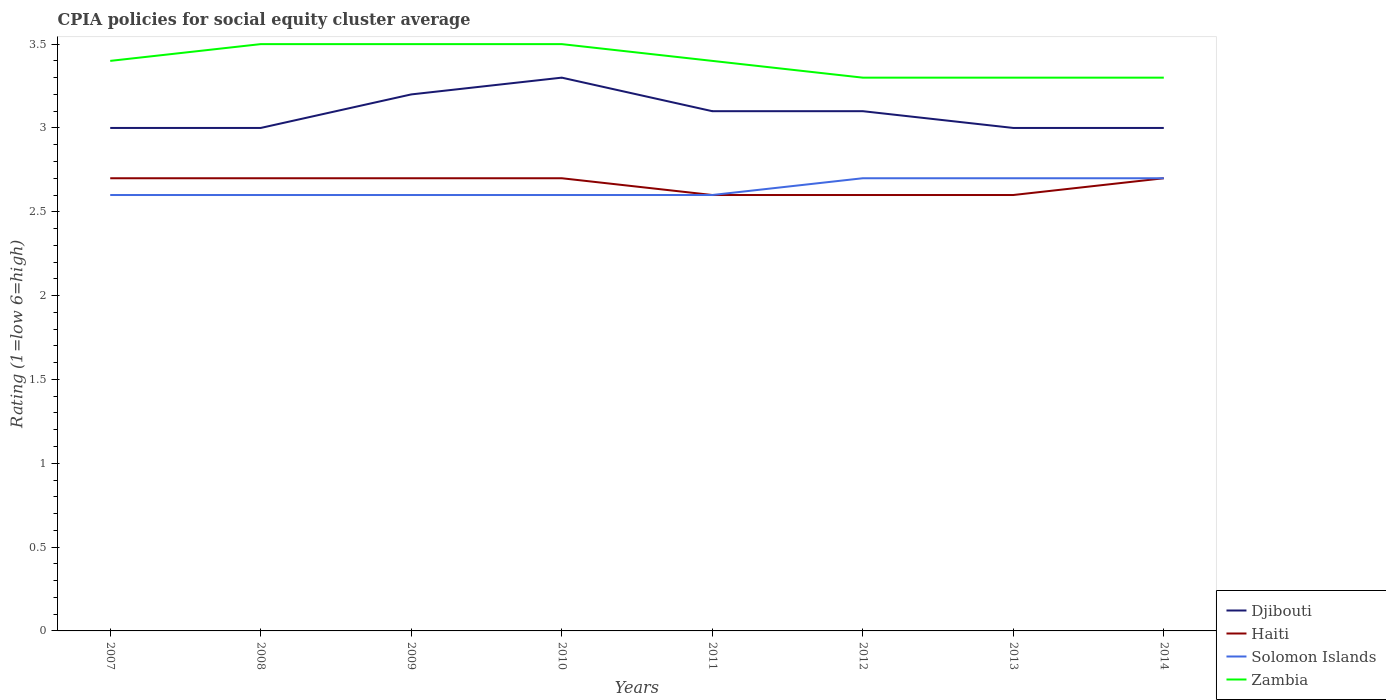Does the line corresponding to Solomon Islands intersect with the line corresponding to Zambia?
Make the answer very short. No. Across all years, what is the maximum CPIA rating in Djibouti?
Give a very brief answer. 3. In which year was the CPIA rating in Zambia maximum?
Give a very brief answer. 2012. What is the total CPIA rating in Djibouti in the graph?
Give a very brief answer. 0. What is the difference between the highest and the second highest CPIA rating in Djibouti?
Ensure brevity in your answer.  0.3. Is the CPIA rating in Djibouti strictly greater than the CPIA rating in Haiti over the years?
Your answer should be compact. No. Are the values on the major ticks of Y-axis written in scientific E-notation?
Your answer should be very brief. No. Does the graph contain any zero values?
Keep it short and to the point. No. Where does the legend appear in the graph?
Give a very brief answer. Bottom right. How many legend labels are there?
Your response must be concise. 4. How are the legend labels stacked?
Provide a short and direct response. Vertical. What is the title of the graph?
Your answer should be compact. CPIA policies for social equity cluster average. Does "Panama" appear as one of the legend labels in the graph?
Your answer should be very brief. No. What is the label or title of the X-axis?
Your answer should be very brief. Years. What is the Rating (1=low 6=high) of Djibouti in 2007?
Your response must be concise. 3. What is the Rating (1=low 6=high) of Haiti in 2007?
Offer a terse response. 2.7. What is the Rating (1=low 6=high) of Zambia in 2007?
Provide a succinct answer. 3.4. What is the Rating (1=low 6=high) in Haiti in 2008?
Your answer should be very brief. 2.7. What is the Rating (1=low 6=high) in Solomon Islands in 2008?
Offer a terse response. 2.6. What is the Rating (1=low 6=high) of Zambia in 2008?
Ensure brevity in your answer.  3.5. What is the Rating (1=low 6=high) of Zambia in 2009?
Offer a terse response. 3.5. What is the Rating (1=low 6=high) in Djibouti in 2010?
Provide a short and direct response. 3.3. What is the Rating (1=low 6=high) of Haiti in 2010?
Make the answer very short. 2.7. What is the Rating (1=low 6=high) in Solomon Islands in 2010?
Ensure brevity in your answer.  2.6. What is the Rating (1=low 6=high) in Zambia in 2010?
Provide a succinct answer. 3.5. What is the Rating (1=low 6=high) of Haiti in 2012?
Make the answer very short. 2.6. What is the Rating (1=low 6=high) in Haiti in 2013?
Keep it short and to the point. 2.6. What is the Rating (1=low 6=high) in Zambia in 2013?
Ensure brevity in your answer.  3.3. What is the Rating (1=low 6=high) of Zambia in 2014?
Your answer should be very brief. 3.3. Across all years, what is the maximum Rating (1=low 6=high) of Solomon Islands?
Ensure brevity in your answer.  2.7. Across all years, what is the maximum Rating (1=low 6=high) in Zambia?
Offer a very short reply. 3.5. Across all years, what is the minimum Rating (1=low 6=high) in Haiti?
Provide a short and direct response. 2.6. What is the total Rating (1=low 6=high) of Djibouti in the graph?
Make the answer very short. 24.7. What is the total Rating (1=low 6=high) of Haiti in the graph?
Offer a very short reply. 21.3. What is the total Rating (1=low 6=high) of Solomon Islands in the graph?
Keep it short and to the point. 21.1. What is the total Rating (1=low 6=high) of Zambia in the graph?
Keep it short and to the point. 27.2. What is the difference between the Rating (1=low 6=high) of Zambia in 2007 and that in 2008?
Offer a very short reply. -0.1. What is the difference between the Rating (1=low 6=high) of Djibouti in 2007 and that in 2009?
Ensure brevity in your answer.  -0.2. What is the difference between the Rating (1=low 6=high) in Haiti in 2007 and that in 2009?
Ensure brevity in your answer.  0. What is the difference between the Rating (1=low 6=high) in Djibouti in 2007 and that in 2010?
Offer a terse response. -0.3. What is the difference between the Rating (1=low 6=high) in Solomon Islands in 2007 and that in 2010?
Offer a terse response. 0. What is the difference between the Rating (1=low 6=high) in Zambia in 2007 and that in 2010?
Your response must be concise. -0.1. What is the difference between the Rating (1=low 6=high) of Djibouti in 2007 and that in 2012?
Make the answer very short. -0.1. What is the difference between the Rating (1=low 6=high) in Haiti in 2007 and that in 2012?
Give a very brief answer. 0.1. What is the difference between the Rating (1=low 6=high) of Solomon Islands in 2007 and that in 2012?
Give a very brief answer. -0.1. What is the difference between the Rating (1=low 6=high) of Zambia in 2007 and that in 2012?
Offer a very short reply. 0.1. What is the difference between the Rating (1=low 6=high) in Djibouti in 2007 and that in 2014?
Make the answer very short. 0. What is the difference between the Rating (1=low 6=high) of Solomon Islands in 2007 and that in 2014?
Your answer should be compact. -0.1. What is the difference between the Rating (1=low 6=high) of Zambia in 2007 and that in 2014?
Ensure brevity in your answer.  0.1. What is the difference between the Rating (1=low 6=high) in Djibouti in 2008 and that in 2009?
Keep it short and to the point. -0.2. What is the difference between the Rating (1=low 6=high) of Haiti in 2008 and that in 2009?
Provide a short and direct response. 0. What is the difference between the Rating (1=low 6=high) in Zambia in 2008 and that in 2009?
Give a very brief answer. 0. What is the difference between the Rating (1=low 6=high) in Haiti in 2008 and that in 2010?
Give a very brief answer. 0. What is the difference between the Rating (1=low 6=high) of Haiti in 2008 and that in 2011?
Your response must be concise. 0.1. What is the difference between the Rating (1=low 6=high) of Zambia in 2008 and that in 2011?
Offer a very short reply. 0.1. What is the difference between the Rating (1=low 6=high) in Djibouti in 2008 and that in 2012?
Make the answer very short. -0.1. What is the difference between the Rating (1=low 6=high) of Solomon Islands in 2008 and that in 2012?
Provide a succinct answer. -0.1. What is the difference between the Rating (1=low 6=high) in Solomon Islands in 2008 and that in 2013?
Provide a succinct answer. -0.1. What is the difference between the Rating (1=low 6=high) of Zambia in 2008 and that in 2014?
Ensure brevity in your answer.  0.2. What is the difference between the Rating (1=low 6=high) of Djibouti in 2009 and that in 2010?
Your response must be concise. -0.1. What is the difference between the Rating (1=low 6=high) of Haiti in 2009 and that in 2010?
Offer a terse response. 0. What is the difference between the Rating (1=low 6=high) of Haiti in 2009 and that in 2011?
Ensure brevity in your answer.  0.1. What is the difference between the Rating (1=low 6=high) of Solomon Islands in 2009 and that in 2011?
Give a very brief answer. 0. What is the difference between the Rating (1=low 6=high) in Zambia in 2009 and that in 2012?
Offer a very short reply. 0.2. What is the difference between the Rating (1=low 6=high) in Djibouti in 2009 and that in 2013?
Offer a very short reply. 0.2. What is the difference between the Rating (1=low 6=high) in Haiti in 2009 and that in 2013?
Ensure brevity in your answer.  0.1. What is the difference between the Rating (1=low 6=high) in Solomon Islands in 2009 and that in 2013?
Your answer should be compact. -0.1. What is the difference between the Rating (1=low 6=high) of Djibouti in 2010 and that in 2011?
Keep it short and to the point. 0.2. What is the difference between the Rating (1=low 6=high) in Haiti in 2010 and that in 2011?
Your response must be concise. 0.1. What is the difference between the Rating (1=low 6=high) in Zambia in 2010 and that in 2011?
Make the answer very short. 0.1. What is the difference between the Rating (1=low 6=high) of Haiti in 2010 and that in 2012?
Keep it short and to the point. 0.1. What is the difference between the Rating (1=low 6=high) in Solomon Islands in 2010 and that in 2012?
Ensure brevity in your answer.  -0.1. What is the difference between the Rating (1=low 6=high) in Zambia in 2010 and that in 2012?
Offer a very short reply. 0.2. What is the difference between the Rating (1=low 6=high) of Djibouti in 2010 and that in 2013?
Give a very brief answer. 0.3. What is the difference between the Rating (1=low 6=high) in Djibouti in 2010 and that in 2014?
Offer a terse response. 0.3. What is the difference between the Rating (1=low 6=high) in Haiti in 2010 and that in 2014?
Keep it short and to the point. 0. What is the difference between the Rating (1=low 6=high) in Zambia in 2010 and that in 2014?
Provide a short and direct response. 0.2. What is the difference between the Rating (1=low 6=high) of Djibouti in 2011 and that in 2014?
Ensure brevity in your answer.  0.1. What is the difference between the Rating (1=low 6=high) in Haiti in 2011 and that in 2014?
Provide a succinct answer. -0.1. What is the difference between the Rating (1=low 6=high) in Solomon Islands in 2011 and that in 2014?
Your answer should be compact. -0.1. What is the difference between the Rating (1=low 6=high) of Zambia in 2011 and that in 2014?
Make the answer very short. 0.1. What is the difference between the Rating (1=low 6=high) of Djibouti in 2012 and that in 2014?
Offer a very short reply. 0.1. What is the difference between the Rating (1=low 6=high) in Solomon Islands in 2013 and that in 2014?
Ensure brevity in your answer.  0. What is the difference between the Rating (1=low 6=high) in Zambia in 2013 and that in 2014?
Give a very brief answer. 0. What is the difference between the Rating (1=low 6=high) of Djibouti in 2007 and the Rating (1=low 6=high) of Solomon Islands in 2008?
Your response must be concise. 0.4. What is the difference between the Rating (1=low 6=high) of Haiti in 2007 and the Rating (1=low 6=high) of Zambia in 2008?
Your response must be concise. -0.8. What is the difference between the Rating (1=low 6=high) in Djibouti in 2007 and the Rating (1=low 6=high) in Haiti in 2009?
Make the answer very short. 0.3. What is the difference between the Rating (1=low 6=high) in Djibouti in 2007 and the Rating (1=low 6=high) in Solomon Islands in 2009?
Make the answer very short. 0.4. What is the difference between the Rating (1=low 6=high) of Haiti in 2007 and the Rating (1=low 6=high) of Zambia in 2009?
Keep it short and to the point. -0.8. What is the difference between the Rating (1=low 6=high) in Djibouti in 2007 and the Rating (1=low 6=high) in Haiti in 2010?
Your response must be concise. 0.3. What is the difference between the Rating (1=low 6=high) of Djibouti in 2007 and the Rating (1=low 6=high) of Zambia in 2010?
Your response must be concise. -0.5. What is the difference between the Rating (1=low 6=high) of Djibouti in 2007 and the Rating (1=low 6=high) of Solomon Islands in 2011?
Your answer should be compact. 0.4. What is the difference between the Rating (1=low 6=high) in Djibouti in 2007 and the Rating (1=low 6=high) in Zambia in 2011?
Offer a terse response. -0.4. What is the difference between the Rating (1=low 6=high) in Djibouti in 2007 and the Rating (1=low 6=high) in Solomon Islands in 2012?
Make the answer very short. 0.3. What is the difference between the Rating (1=low 6=high) of Solomon Islands in 2007 and the Rating (1=low 6=high) of Zambia in 2012?
Offer a terse response. -0.7. What is the difference between the Rating (1=low 6=high) in Djibouti in 2007 and the Rating (1=low 6=high) in Zambia in 2013?
Offer a terse response. -0.3. What is the difference between the Rating (1=low 6=high) of Solomon Islands in 2007 and the Rating (1=low 6=high) of Zambia in 2013?
Keep it short and to the point. -0.7. What is the difference between the Rating (1=low 6=high) in Djibouti in 2007 and the Rating (1=low 6=high) in Solomon Islands in 2014?
Your answer should be compact. 0.3. What is the difference between the Rating (1=low 6=high) in Haiti in 2007 and the Rating (1=low 6=high) in Solomon Islands in 2014?
Your answer should be very brief. 0. What is the difference between the Rating (1=low 6=high) in Haiti in 2007 and the Rating (1=low 6=high) in Zambia in 2014?
Ensure brevity in your answer.  -0.6. What is the difference between the Rating (1=low 6=high) in Solomon Islands in 2007 and the Rating (1=low 6=high) in Zambia in 2014?
Offer a very short reply. -0.7. What is the difference between the Rating (1=low 6=high) of Djibouti in 2008 and the Rating (1=low 6=high) of Solomon Islands in 2009?
Your answer should be very brief. 0.4. What is the difference between the Rating (1=low 6=high) in Haiti in 2008 and the Rating (1=low 6=high) in Solomon Islands in 2009?
Provide a succinct answer. 0.1. What is the difference between the Rating (1=low 6=high) of Haiti in 2008 and the Rating (1=low 6=high) of Zambia in 2009?
Offer a terse response. -0.8. What is the difference between the Rating (1=low 6=high) of Djibouti in 2008 and the Rating (1=low 6=high) of Solomon Islands in 2010?
Give a very brief answer. 0.4. What is the difference between the Rating (1=low 6=high) in Haiti in 2008 and the Rating (1=low 6=high) in Solomon Islands in 2010?
Provide a succinct answer. 0.1. What is the difference between the Rating (1=low 6=high) in Solomon Islands in 2008 and the Rating (1=low 6=high) in Zambia in 2010?
Ensure brevity in your answer.  -0.9. What is the difference between the Rating (1=low 6=high) of Djibouti in 2008 and the Rating (1=low 6=high) of Haiti in 2011?
Your answer should be very brief. 0.4. What is the difference between the Rating (1=low 6=high) in Djibouti in 2008 and the Rating (1=low 6=high) in Solomon Islands in 2011?
Your response must be concise. 0.4. What is the difference between the Rating (1=low 6=high) of Djibouti in 2008 and the Rating (1=low 6=high) of Zambia in 2011?
Give a very brief answer. -0.4. What is the difference between the Rating (1=low 6=high) of Haiti in 2008 and the Rating (1=low 6=high) of Solomon Islands in 2011?
Provide a succinct answer. 0.1. What is the difference between the Rating (1=low 6=high) of Haiti in 2008 and the Rating (1=low 6=high) of Zambia in 2011?
Your answer should be very brief. -0.7. What is the difference between the Rating (1=low 6=high) of Djibouti in 2008 and the Rating (1=low 6=high) of Zambia in 2012?
Make the answer very short. -0.3. What is the difference between the Rating (1=low 6=high) in Solomon Islands in 2008 and the Rating (1=low 6=high) in Zambia in 2012?
Give a very brief answer. -0.7. What is the difference between the Rating (1=low 6=high) of Djibouti in 2008 and the Rating (1=low 6=high) of Solomon Islands in 2013?
Make the answer very short. 0.3. What is the difference between the Rating (1=low 6=high) in Djibouti in 2008 and the Rating (1=low 6=high) in Haiti in 2014?
Ensure brevity in your answer.  0.3. What is the difference between the Rating (1=low 6=high) in Djibouti in 2008 and the Rating (1=low 6=high) in Solomon Islands in 2014?
Provide a succinct answer. 0.3. What is the difference between the Rating (1=low 6=high) in Haiti in 2008 and the Rating (1=low 6=high) in Solomon Islands in 2014?
Your response must be concise. 0. What is the difference between the Rating (1=low 6=high) of Haiti in 2008 and the Rating (1=low 6=high) of Zambia in 2014?
Give a very brief answer. -0.6. What is the difference between the Rating (1=low 6=high) of Djibouti in 2009 and the Rating (1=low 6=high) of Haiti in 2010?
Offer a terse response. 0.5. What is the difference between the Rating (1=low 6=high) of Solomon Islands in 2009 and the Rating (1=low 6=high) of Zambia in 2010?
Provide a short and direct response. -0.9. What is the difference between the Rating (1=low 6=high) in Haiti in 2009 and the Rating (1=low 6=high) in Zambia in 2011?
Ensure brevity in your answer.  -0.7. What is the difference between the Rating (1=low 6=high) in Solomon Islands in 2009 and the Rating (1=low 6=high) in Zambia in 2011?
Give a very brief answer. -0.8. What is the difference between the Rating (1=low 6=high) in Djibouti in 2009 and the Rating (1=low 6=high) in Haiti in 2012?
Provide a short and direct response. 0.6. What is the difference between the Rating (1=low 6=high) of Djibouti in 2009 and the Rating (1=low 6=high) of Zambia in 2012?
Your answer should be compact. -0.1. What is the difference between the Rating (1=low 6=high) of Djibouti in 2009 and the Rating (1=low 6=high) of Solomon Islands in 2013?
Your answer should be compact. 0.5. What is the difference between the Rating (1=low 6=high) of Haiti in 2009 and the Rating (1=low 6=high) of Solomon Islands in 2013?
Ensure brevity in your answer.  0. What is the difference between the Rating (1=low 6=high) in Djibouti in 2009 and the Rating (1=low 6=high) in Zambia in 2014?
Provide a succinct answer. -0.1. What is the difference between the Rating (1=low 6=high) of Djibouti in 2010 and the Rating (1=low 6=high) of Zambia in 2011?
Give a very brief answer. -0.1. What is the difference between the Rating (1=low 6=high) of Haiti in 2010 and the Rating (1=low 6=high) of Solomon Islands in 2011?
Your answer should be very brief. 0.1. What is the difference between the Rating (1=low 6=high) of Solomon Islands in 2010 and the Rating (1=low 6=high) of Zambia in 2011?
Ensure brevity in your answer.  -0.8. What is the difference between the Rating (1=low 6=high) of Djibouti in 2010 and the Rating (1=low 6=high) of Haiti in 2012?
Provide a succinct answer. 0.7. What is the difference between the Rating (1=low 6=high) in Djibouti in 2010 and the Rating (1=low 6=high) in Zambia in 2012?
Make the answer very short. 0. What is the difference between the Rating (1=low 6=high) of Haiti in 2010 and the Rating (1=low 6=high) of Zambia in 2012?
Offer a very short reply. -0.6. What is the difference between the Rating (1=low 6=high) of Djibouti in 2010 and the Rating (1=low 6=high) of Haiti in 2013?
Provide a short and direct response. 0.7. What is the difference between the Rating (1=low 6=high) of Djibouti in 2010 and the Rating (1=low 6=high) of Zambia in 2013?
Your response must be concise. 0. What is the difference between the Rating (1=low 6=high) in Djibouti in 2010 and the Rating (1=low 6=high) in Haiti in 2014?
Offer a very short reply. 0.6. What is the difference between the Rating (1=low 6=high) of Solomon Islands in 2010 and the Rating (1=low 6=high) of Zambia in 2014?
Your answer should be compact. -0.7. What is the difference between the Rating (1=low 6=high) in Djibouti in 2011 and the Rating (1=low 6=high) in Haiti in 2012?
Your response must be concise. 0.5. What is the difference between the Rating (1=low 6=high) in Djibouti in 2011 and the Rating (1=low 6=high) in Solomon Islands in 2012?
Offer a terse response. 0.4. What is the difference between the Rating (1=low 6=high) in Haiti in 2011 and the Rating (1=low 6=high) in Solomon Islands in 2012?
Offer a very short reply. -0.1. What is the difference between the Rating (1=low 6=high) of Haiti in 2011 and the Rating (1=low 6=high) of Solomon Islands in 2013?
Make the answer very short. -0.1. What is the difference between the Rating (1=low 6=high) of Haiti in 2011 and the Rating (1=low 6=high) of Zambia in 2013?
Offer a very short reply. -0.7. What is the difference between the Rating (1=low 6=high) of Djibouti in 2011 and the Rating (1=low 6=high) of Haiti in 2014?
Your answer should be compact. 0.4. What is the difference between the Rating (1=low 6=high) of Djibouti in 2011 and the Rating (1=low 6=high) of Solomon Islands in 2014?
Provide a succinct answer. 0.4. What is the difference between the Rating (1=low 6=high) in Haiti in 2011 and the Rating (1=low 6=high) in Zambia in 2014?
Give a very brief answer. -0.7. What is the difference between the Rating (1=low 6=high) of Djibouti in 2012 and the Rating (1=low 6=high) of Zambia in 2013?
Keep it short and to the point. -0.2. What is the difference between the Rating (1=low 6=high) in Haiti in 2012 and the Rating (1=low 6=high) in Zambia in 2013?
Give a very brief answer. -0.7. What is the difference between the Rating (1=low 6=high) of Solomon Islands in 2012 and the Rating (1=low 6=high) of Zambia in 2013?
Offer a terse response. -0.6. What is the difference between the Rating (1=low 6=high) of Solomon Islands in 2012 and the Rating (1=low 6=high) of Zambia in 2014?
Make the answer very short. -0.6. What is the difference between the Rating (1=low 6=high) in Djibouti in 2013 and the Rating (1=low 6=high) in Solomon Islands in 2014?
Offer a terse response. 0.3. What is the difference between the Rating (1=low 6=high) of Djibouti in 2013 and the Rating (1=low 6=high) of Zambia in 2014?
Provide a short and direct response. -0.3. What is the difference between the Rating (1=low 6=high) in Haiti in 2013 and the Rating (1=low 6=high) in Solomon Islands in 2014?
Your response must be concise. -0.1. What is the difference between the Rating (1=low 6=high) in Solomon Islands in 2013 and the Rating (1=low 6=high) in Zambia in 2014?
Provide a short and direct response. -0.6. What is the average Rating (1=low 6=high) of Djibouti per year?
Your answer should be compact. 3.09. What is the average Rating (1=low 6=high) in Haiti per year?
Your response must be concise. 2.66. What is the average Rating (1=low 6=high) in Solomon Islands per year?
Provide a short and direct response. 2.64. In the year 2007, what is the difference between the Rating (1=low 6=high) of Djibouti and Rating (1=low 6=high) of Haiti?
Make the answer very short. 0.3. In the year 2007, what is the difference between the Rating (1=low 6=high) of Djibouti and Rating (1=low 6=high) of Solomon Islands?
Offer a terse response. 0.4. In the year 2007, what is the difference between the Rating (1=low 6=high) of Haiti and Rating (1=low 6=high) of Solomon Islands?
Offer a very short reply. 0.1. In the year 2007, what is the difference between the Rating (1=low 6=high) in Solomon Islands and Rating (1=low 6=high) in Zambia?
Provide a short and direct response. -0.8. In the year 2008, what is the difference between the Rating (1=low 6=high) of Djibouti and Rating (1=low 6=high) of Haiti?
Give a very brief answer. 0.3. In the year 2008, what is the difference between the Rating (1=low 6=high) in Djibouti and Rating (1=low 6=high) in Solomon Islands?
Provide a short and direct response. 0.4. In the year 2008, what is the difference between the Rating (1=low 6=high) in Haiti and Rating (1=low 6=high) in Solomon Islands?
Keep it short and to the point. 0.1. In the year 2009, what is the difference between the Rating (1=low 6=high) in Djibouti and Rating (1=low 6=high) in Solomon Islands?
Ensure brevity in your answer.  0.6. In the year 2009, what is the difference between the Rating (1=low 6=high) in Haiti and Rating (1=low 6=high) in Solomon Islands?
Ensure brevity in your answer.  0.1. In the year 2010, what is the difference between the Rating (1=low 6=high) in Djibouti and Rating (1=low 6=high) in Solomon Islands?
Keep it short and to the point. 0.7. In the year 2010, what is the difference between the Rating (1=low 6=high) in Haiti and Rating (1=low 6=high) in Zambia?
Provide a short and direct response. -0.8. In the year 2011, what is the difference between the Rating (1=low 6=high) in Djibouti and Rating (1=low 6=high) in Haiti?
Offer a very short reply. 0.5. In the year 2011, what is the difference between the Rating (1=low 6=high) in Djibouti and Rating (1=low 6=high) in Zambia?
Provide a succinct answer. -0.3. In the year 2011, what is the difference between the Rating (1=low 6=high) of Solomon Islands and Rating (1=low 6=high) of Zambia?
Ensure brevity in your answer.  -0.8. In the year 2013, what is the difference between the Rating (1=low 6=high) of Djibouti and Rating (1=low 6=high) of Zambia?
Ensure brevity in your answer.  -0.3. In the year 2013, what is the difference between the Rating (1=low 6=high) in Haiti and Rating (1=low 6=high) in Solomon Islands?
Ensure brevity in your answer.  -0.1. In the year 2013, what is the difference between the Rating (1=low 6=high) in Haiti and Rating (1=low 6=high) in Zambia?
Provide a succinct answer. -0.7. In the year 2014, what is the difference between the Rating (1=low 6=high) of Djibouti and Rating (1=low 6=high) of Haiti?
Offer a terse response. 0.3. In the year 2014, what is the difference between the Rating (1=low 6=high) of Djibouti and Rating (1=low 6=high) of Solomon Islands?
Ensure brevity in your answer.  0.3. In the year 2014, what is the difference between the Rating (1=low 6=high) of Haiti and Rating (1=low 6=high) of Zambia?
Provide a succinct answer. -0.6. What is the ratio of the Rating (1=low 6=high) in Zambia in 2007 to that in 2008?
Your answer should be compact. 0.97. What is the ratio of the Rating (1=low 6=high) of Djibouti in 2007 to that in 2009?
Your answer should be very brief. 0.94. What is the ratio of the Rating (1=low 6=high) of Haiti in 2007 to that in 2009?
Your answer should be very brief. 1. What is the ratio of the Rating (1=low 6=high) of Zambia in 2007 to that in 2009?
Offer a very short reply. 0.97. What is the ratio of the Rating (1=low 6=high) of Haiti in 2007 to that in 2010?
Make the answer very short. 1. What is the ratio of the Rating (1=low 6=high) of Zambia in 2007 to that in 2010?
Make the answer very short. 0.97. What is the ratio of the Rating (1=low 6=high) of Haiti in 2007 to that in 2011?
Offer a terse response. 1.04. What is the ratio of the Rating (1=low 6=high) of Solomon Islands in 2007 to that in 2011?
Keep it short and to the point. 1. What is the ratio of the Rating (1=low 6=high) of Haiti in 2007 to that in 2012?
Give a very brief answer. 1.04. What is the ratio of the Rating (1=low 6=high) of Solomon Islands in 2007 to that in 2012?
Your answer should be compact. 0.96. What is the ratio of the Rating (1=low 6=high) of Zambia in 2007 to that in 2012?
Ensure brevity in your answer.  1.03. What is the ratio of the Rating (1=low 6=high) of Djibouti in 2007 to that in 2013?
Give a very brief answer. 1. What is the ratio of the Rating (1=low 6=high) of Haiti in 2007 to that in 2013?
Make the answer very short. 1.04. What is the ratio of the Rating (1=low 6=high) of Zambia in 2007 to that in 2013?
Ensure brevity in your answer.  1.03. What is the ratio of the Rating (1=low 6=high) of Haiti in 2007 to that in 2014?
Keep it short and to the point. 1. What is the ratio of the Rating (1=low 6=high) in Solomon Islands in 2007 to that in 2014?
Your answer should be compact. 0.96. What is the ratio of the Rating (1=low 6=high) in Zambia in 2007 to that in 2014?
Your response must be concise. 1.03. What is the ratio of the Rating (1=low 6=high) in Djibouti in 2008 to that in 2009?
Keep it short and to the point. 0.94. What is the ratio of the Rating (1=low 6=high) of Haiti in 2008 to that in 2009?
Your answer should be compact. 1. What is the ratio of the Rating (1=low 6=high) of Solomon Islands in 2008 to that in 2009?
Make the answer very short. 1. What is the ratio of the Rating (1=low 6=high) in Haiti in 2008 to that in 2010?
Offer a terse response. 1. What is the ratio of the Rating (1=low 6=high) in Solomon Islands in 2008 to that in 2010?
Ensure brevity in your answer.  1. What is the ratio of the Rating (1=low 6=high) of Zambia in 2008 to that in 2010?
Your answer should be compact. 1. What is the ratio of the Rating (1=low 6=high) of Djibouti in 2008 to that in 2011?
Ensure brevity in your answer.  0.97. What is the ratio of the Rating (1=low 6=high) in Haiti in 2008 to that in 2011?
Your response must be concise. 1.04. What is the ratio of the Rating (1=low 6=high) of Solomon Islands in 2008 to that in 2011?
Provide a short and direct response. 1. What is the ratio of the Rating (1=low 6=high) of Zambia in 2008 to that in 2011?
Keep it short and to the point. 1.03. What is the ratio of the Rating (1=low 6=high) of Djibouti in 2008 to that in 2012?
Keep it short and to the point. 0.97. What is the ratio of the Rating (1=low 6=high) in Zambia in 2008 to that in 2012?
Offer a very short reply. 1.06. What is the ratio of the Rating (1=low 6=high) in Djibouti in 2008 to that in 2013?
Offer a terse response. 1. What is the ratio of the Rating (1=low 6=high) of Haiti in 2008 to that in 2013?
Offer a terse response. 1.04. What is the ratio of the Rating (1=low 6=high) of Solomon Islands in 2008 to that in 2013?
Offer a terse response. 0.96. What is the ratio of the Rating (1=low 6=high) in Zambia in 2008 to that in 2013?
Your response must be concise. 1.06. What is the ratio of the Rating (1=low 6=high) in Zambia in 2008 to that in 2014?
Your answer should be compact. 1.06. What is the ratio of the Rating (1=low 6=high) in Djibouti in 2009 to that in 2010?
Provide a short and direct response. 0.97. What is the ratio of the Rating (1=low 6=high) in Haiti in 2009 to that in 2010?
Make the answer very short. 1. What is the ratio of the Rating (1=low 6=high) in Solomon Islands in 2009 to that in 2010?
Provide a succinct answer. 1. What is the ratio of the Rating (1=low 6=high) in Zambia in 2009 to that in 2010?
Make the answer very short. 1. What is the ratio of the Rating (1=low 6=high) in Djibouti in 2009 to that in 2011?
Provide a short and direct response. 1.03. What is the ratio of the Rating (1=low 6=high) in Haiti in 2009 to that in 2011?
Your answer should be compact. 1.04. What is the ratio of the Rating (1=low 6=high) in Zambia in 2009 to that in 2011?
Give a very brief answer. 1.03. What is the ratio of the Rating (1=low 6=high) in Djibouti in 2009 to that in 2012?
Give a very brief answer. 1.03. What is the ratio of the Rating (1=low 6=high) in Haiti in 2009 to that in 2012?
Provide a short and direct response. 1.04. What is the ratio of the Rating (1=low 6=high) in Zambia in 2009 to that in 2012?
Offer a very short reply. 1.06. What is the ratio of the Rating (1=low 6=high) of Djibouti in 2009 to that in 2013?
Provide a short and direct response. 1.07. What is the ratio of the Rating (1=low 6=high) in Zambia in 2009 to that in 2013?
Ensure brevity in your answer.  1.06. What is the ratio of the Rating (1=low 6=high) in Djibouti in 2009 to that in 2014?
Give a very brief answer. 1.07. What is the ratio of the Rating (1=low 6=high) in Haiti in 2009 to that in 2014?
Your answer should be compact. 1. What is the ratio of the Rating (1=low 6=high) of Solomon Islands in 2009 to that in 2014?
Offer a terse response. 0.96. What is the ratio of the Rating (1=low 6=high) of Zambia in 2009 to that in 2014?
Offer a very short reply. 1.06. What is the ratio of the Rating (1=low 6=high) in Djibouti in 2010 to that in 2011?
Your answer should be very brief. 1.06. What is the ratio of the Rating (1=low 6=high) of Solomon Islands in 2010 to that in 2011?
Give a very brief answer. 1. What is the ratio of the Rating (1=low 6=high) of Zambia in 2010 to that in 2011?
Offer a very short reply. 1.03. What is the ratio of the Rating (1=low 6=high) in Djibouti in 2010 to that in 2012?
Offer a terse response. 1.06. What is the ratio of the Rating (1=low 6=high) in Solomon Islands in 2010 to that in 2012?
Offer a terse response. 0.96. What is the ratio of the Rating (1=low 6=high) in Zambia in 2010 to that in 2012?
Make the answer very short. 1.06. What is the ratio of the Rating (1=low 6=high) in Djibouti in 2010 to that in 2013?
Your response must be concise. 1.1. What is the ratio of the Rating (1=low 6=high) of Solomon Islands in 2010 to that in 2013?
Make the answer very short. 0.96. What is the ratio of the Rating (1=low 6=high) in Zambia in 2010 to that in 2013?
Your answer should be compact. 1.06. What is the ratio of the Rating (1=low 6=high) in Solomon Islands in 2010 to that in 2014?
Ensure brevity in your answer.  0.96. What is the ratio of the Rating (1=low 6=high) in Zambia in 2010 to that in 2014?
Provide a succinct answer. 1.06. What is the ratio of the Rating (1=low 6=high) in Haiti in 2011 to that in 2012?
Ensure brevity in your answer.  1. What is the ratio of the Rating (1=low 6=high) of Solomon Islands in 2011 to that in 2012?
Give a very brief answer. 0.96. What is the ratio of the Rating (1=low 6=high) in Zambia in 2011 to that in 2012?
Give a very brief answer. 1.03. What is the ratio of the Rating (1=low 6=high) of Solomon Islands in 2011 to that in 2013?
Offer a very short reply. 0.96. What is the ratio of the Rating (1=low 6=high) of Zambia in 2011 to that in 2013?
Provide a short and direct response. 1.03. What is the ratio of the Rating (1=low 6=high) of Djibouti in 2011 to that in 2014?
Offer a terse response. 1.03. What is the ratio of the Rating (1=low 6=high) of Solomon Islands in 2011 to that in 2014?
Your answer should be very brief. 0.96. What is the ratio of the Rating (1=low 6=high) of Zambia in 2011 to that in 2014?
Make the answer very short. 1.03. What is the ratio of the Rating (1=low 6=high) in Djibouti in 2012 to that in 2013?
Offer a terse response. 1.03. What is the ratio of the Rating (1=low 6=high) of Haiti in 2012 to that in 2013?
Offer a terse response. 1. What is the ratio of the Rating (1=low 6=high) in Solomon Islands in 2012 to that in 2013?
Provide a short and direct response. 1. What is the ratio of the Rating (1=low 6=high) in Djibouti in 2012 to that in 2014?
Keep it short and to the point. 1.03. What is the ratio of the Rating (1=low 6=high) of Haiti in 2012 to that in 2014?
Provide a short and direct response. 0.96. What is the ratio of the Rating (1=low 6=high) in Zambia in 2012 to that in 2014?
Provide a succinct answer. 1. What is the ratio of the Rating (1=low 6=high) in Djibouti in 2013 to that in 2014?
Provide a succinct answer. 1. What is the ratio of the Rating (1=low 6=high) in Solomon Islands in 2013 to that in 2014?
Make the answer very short. 1. What is the ratio of the Rating (1=low 6=high) of Zambia in 2013 to that in 2014?
Offer a very short reply. 1. What is the difference between the highest and the second highest Rating (1=low 6=high) in Haiti?
Your response must be concise. 0. What is the difference between the highest and the second highest Rating (1=low 6=high) of Zambia?
Provide a short and direct response. 0. What is the difference between the highest and the lowest Rating (1=low 6=high) in Solomon Islands?
Keep it short and to the point. 0.1. What is the difference between the highest and the lowest Rating (1=low 6=high) of Zambia?
Offer a very short reply. 0.2. 